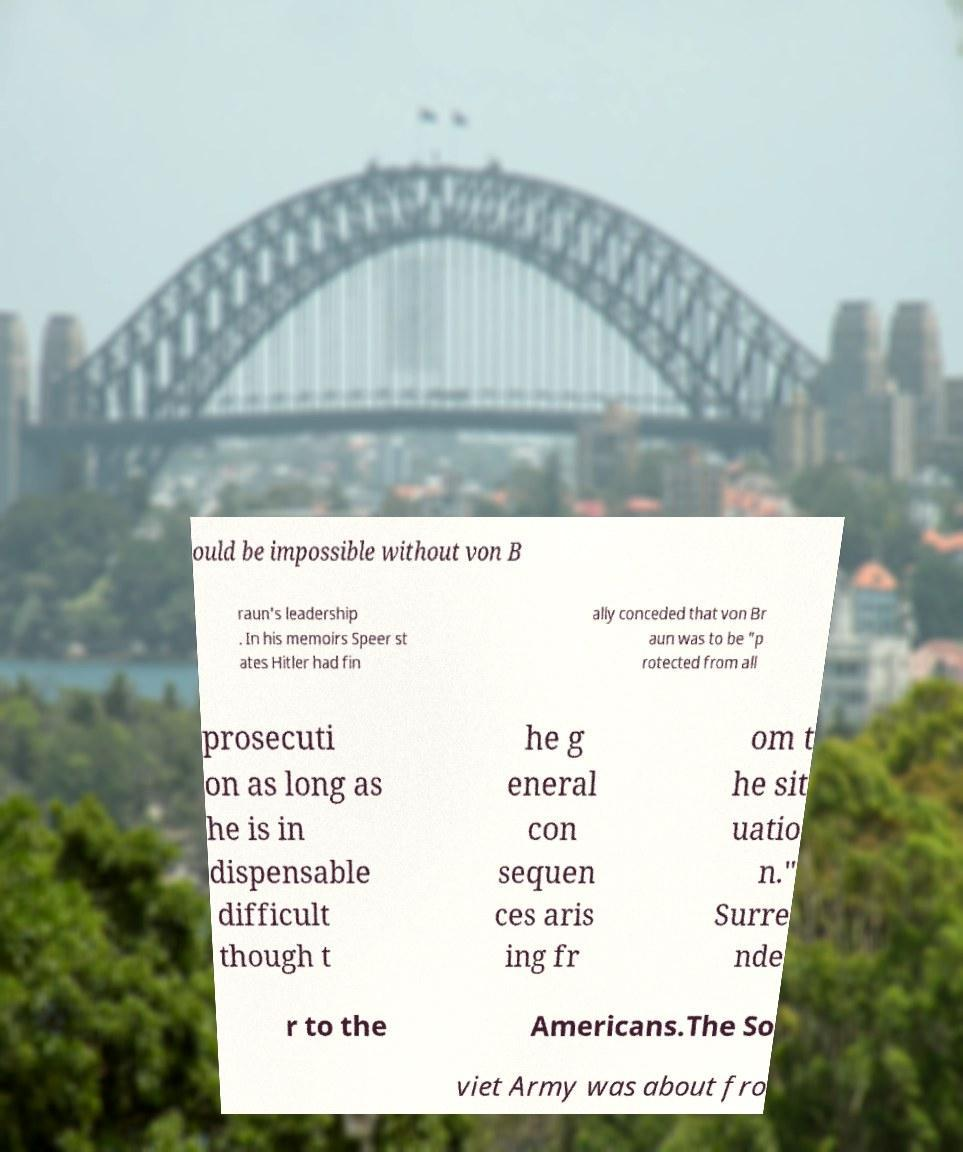Please identify and transcribe the text found in this image. ould be impossible without von B raun's leadership . In his memoirs Speer st ates Hitler had fin ally conceded that von Br aun was to be "p rotected from all prosecuti on as long as he is in dispensable difficult though t he g eneral con sequen ces aris ing fr om t he sit uatio n." Surre nde r to the Americans.The So viet Army was about fro 